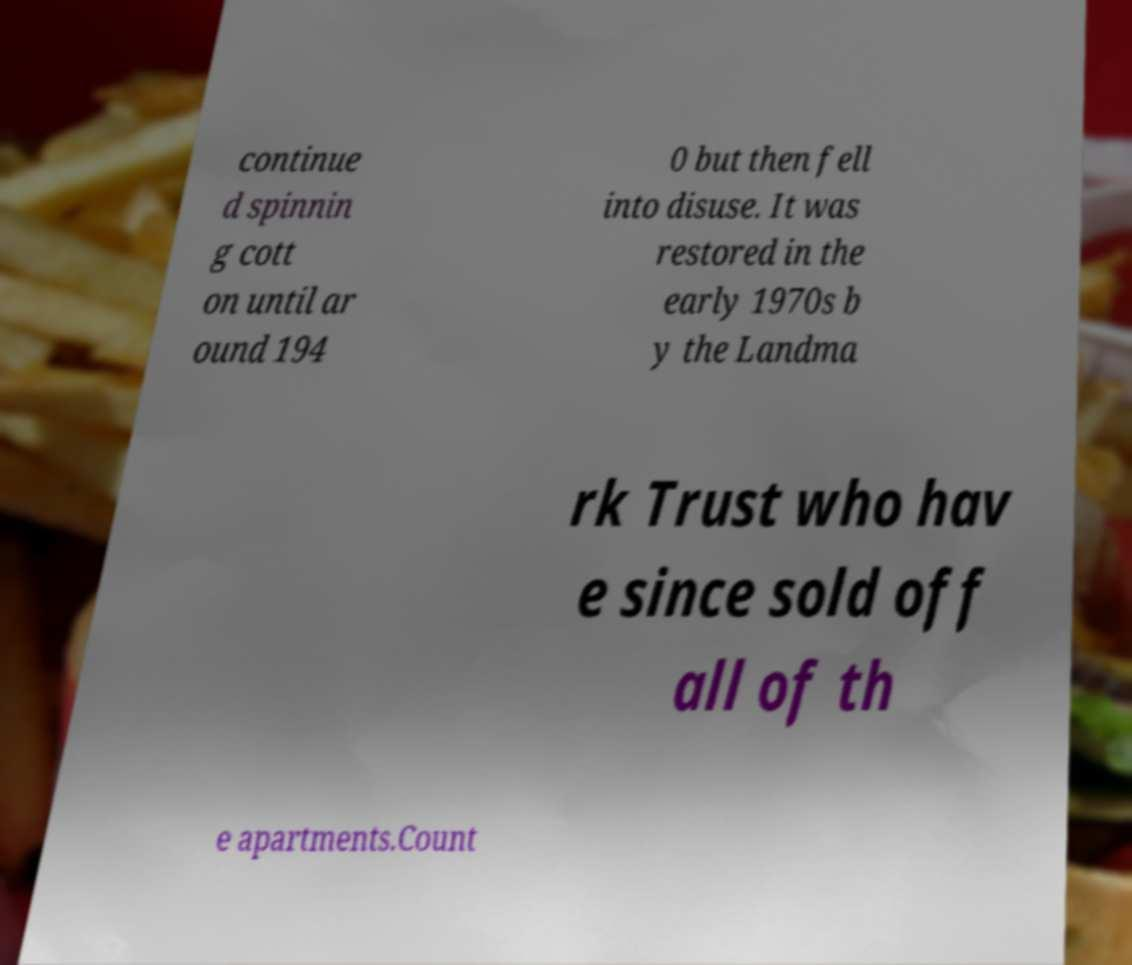Can you read and provide the text displayed in the image?This photo seems to have some interesting text. Can you extract and type it out for me? continue d spinnin g cott on until ar ound 194 0 but then fell into disuse. It was restored in the early 1970s b y the Landma rk Trust who hav e since sold off all of th e apartments.Count 